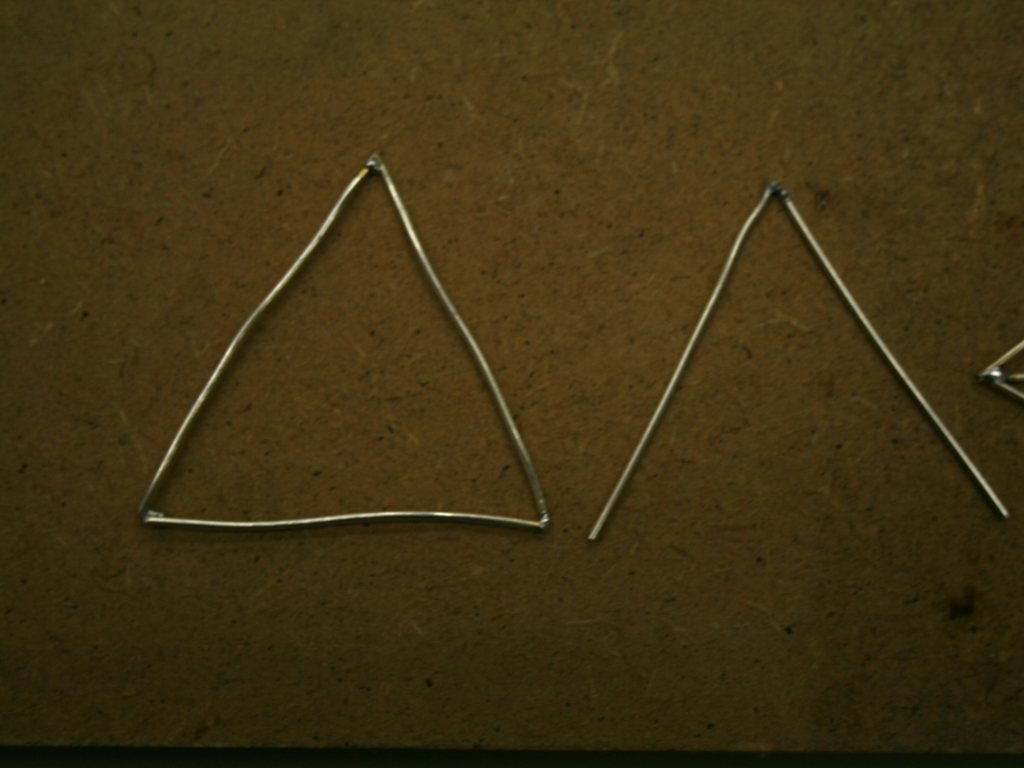What could be the purpose of these wireframe shapes? The wireframe shapes could serve various purposes; they might be simple decorative items, components of a larger art piece, educational models for geometry classes, or maybe even part of a craft or jewelry-making project. 